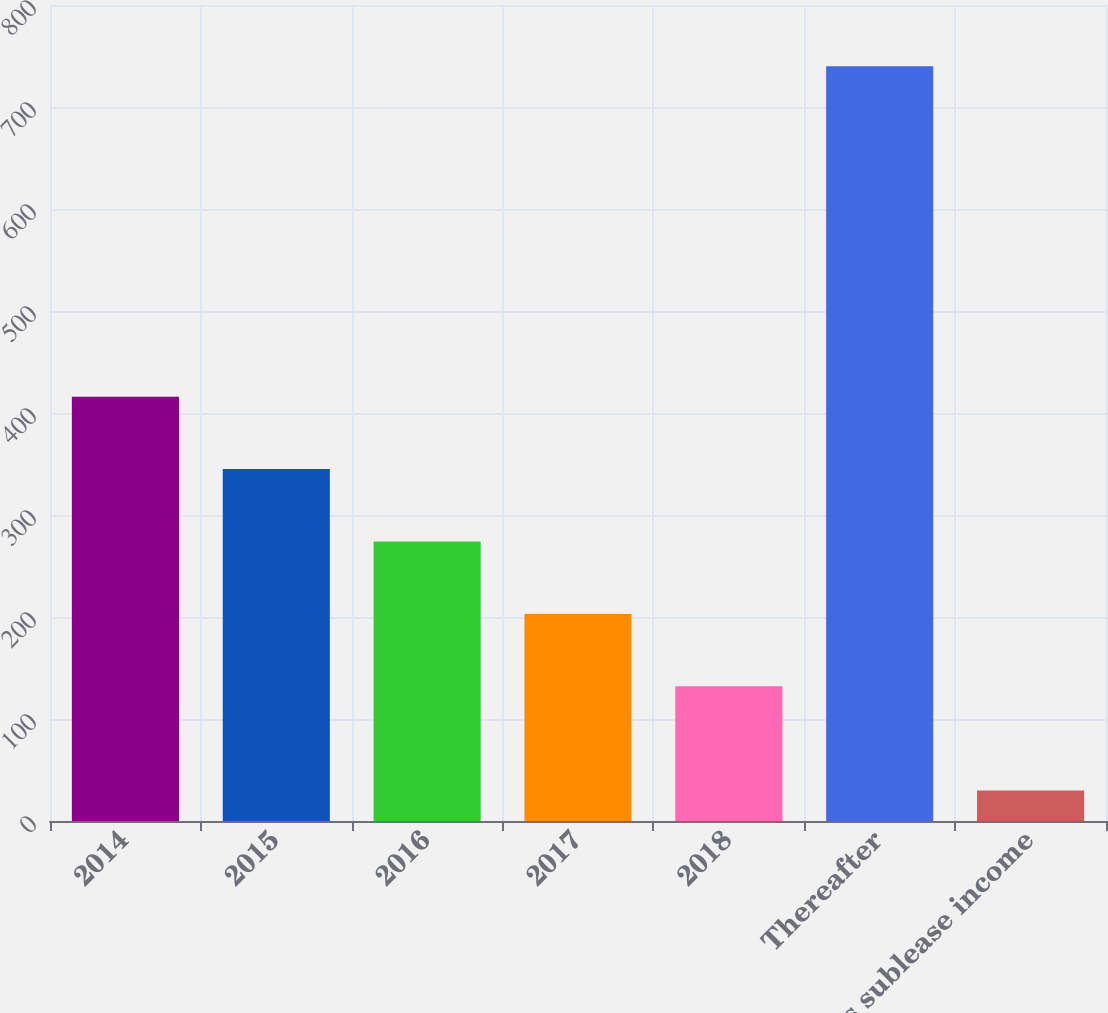Convert chart to OTSL. <chart><loc_0><loc_0><loc_500><loc_500><bar_chart><fcel>2014<fcel>2015<fcel>2016<fcel>2017<fcel>2018<fcel>Thereafter<fcel>Less sublease income<nl><fcel>416<fcel>345<fcel>274<fcel>203<fcel>132<fcel>740<fcel>30<nl></chart> 